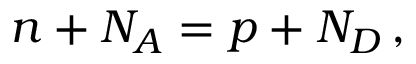Convert formula to latex. <formula><loc_0><loc_0><loc_500><loc_500>n + N _ { A } = p + N _ { D } \, ,</formula> 